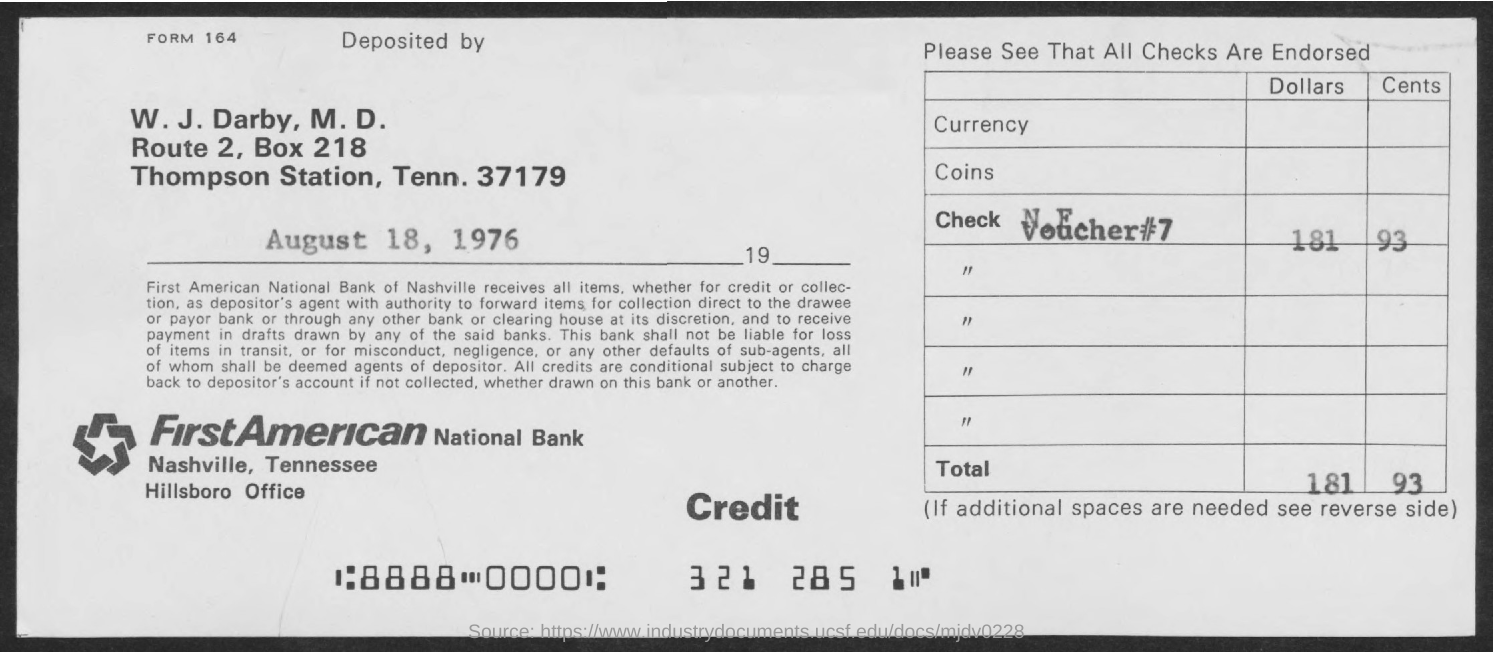What is the Voucher # ?
Your answer should be very brief. 7. What is the Box Number ?
Your answer should be very brief. 218. What is the Bank Name ?
Your response must be concise. FIRSTAMERICAN NATIONAL BANK. 